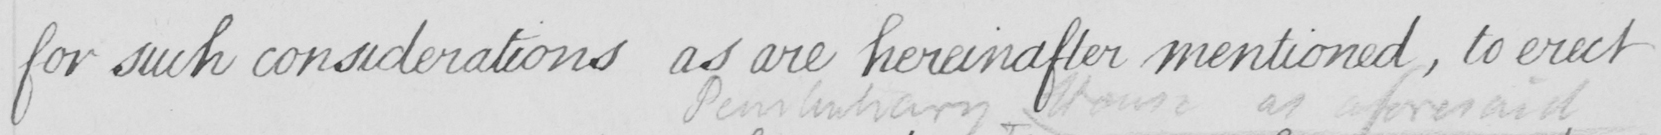What is written in this line of handwriting? for such considerations as are hereinafter mentioned , to erect 